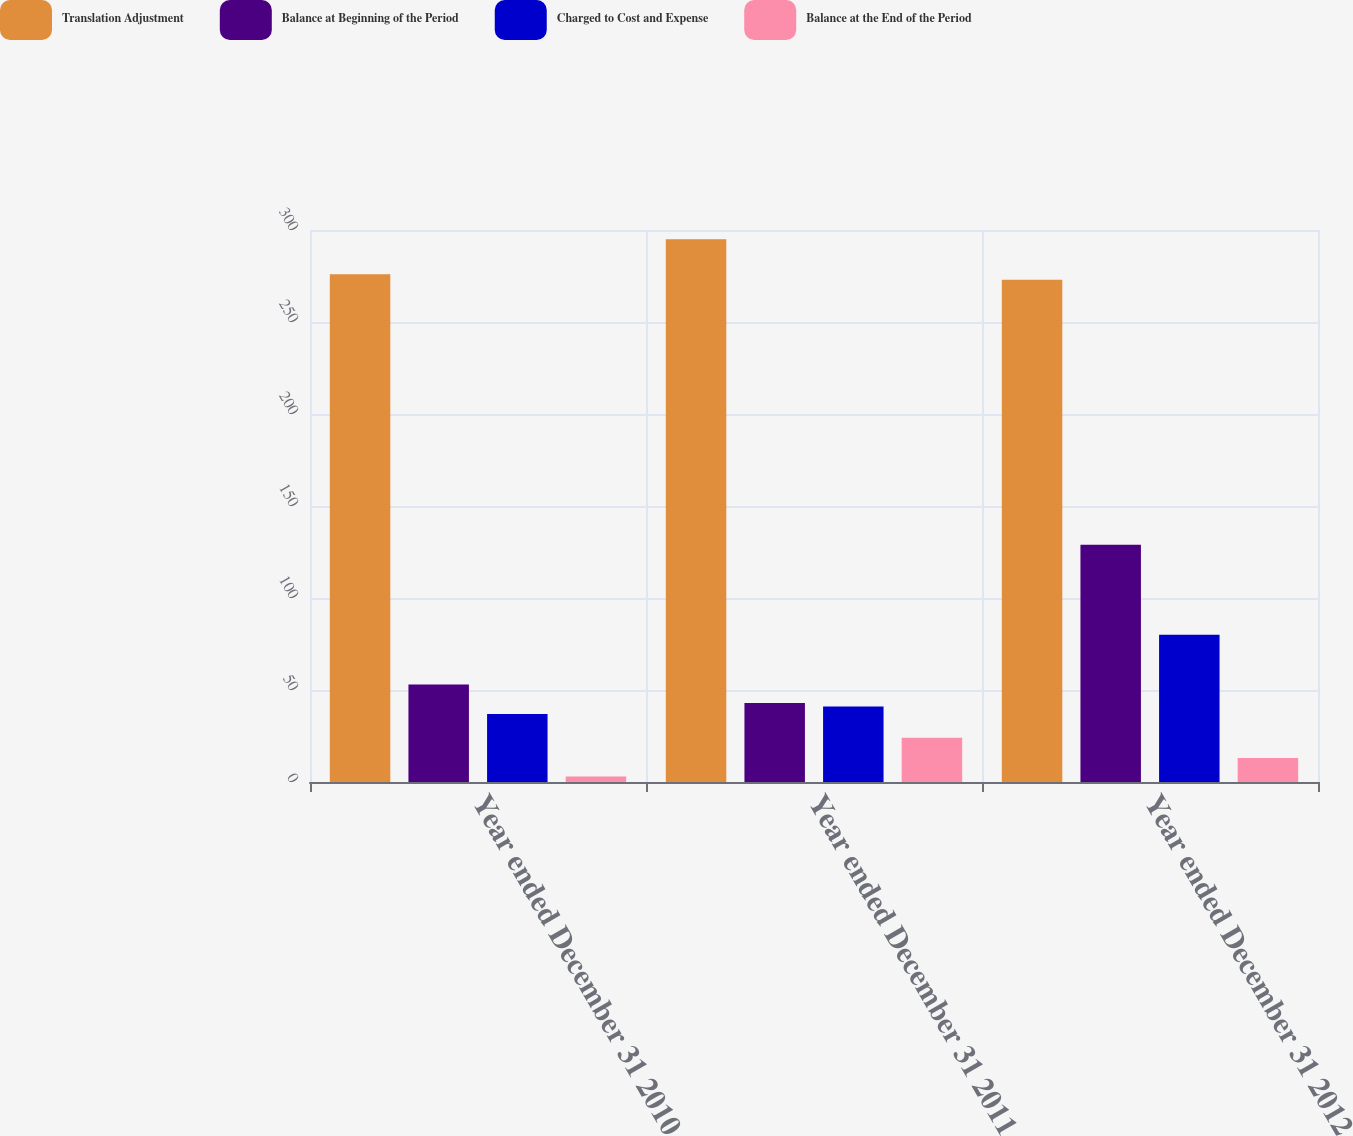<chart> <loc_0><loc_0><loc_500><loc_500><stacked_bar_chart><ecel><fcel>Year ended December 31 2010<fcel>Year ended December 31 2011<fcel>Year ended December 31 2012<nl><fcel>Translation Adjustment<fcel>276<fcel>295<fcel>273<nl><fcel>Balance at Beginning of the Period<fcel>53<fcel>43<fcel>129<nl><fcel>Charged to Cost and Expense<fcel>37<fcel>41<fcel>80<nl><fcel>Balance at the End of the Period<fcel>3<fcel>24<fcel>13<nl></chart> 